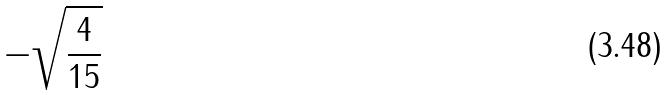<formula> <loc_0><loc_0><loc_500><loc_500>- \sqrt { \frac { 4 } { 1 5 } }</formula> 